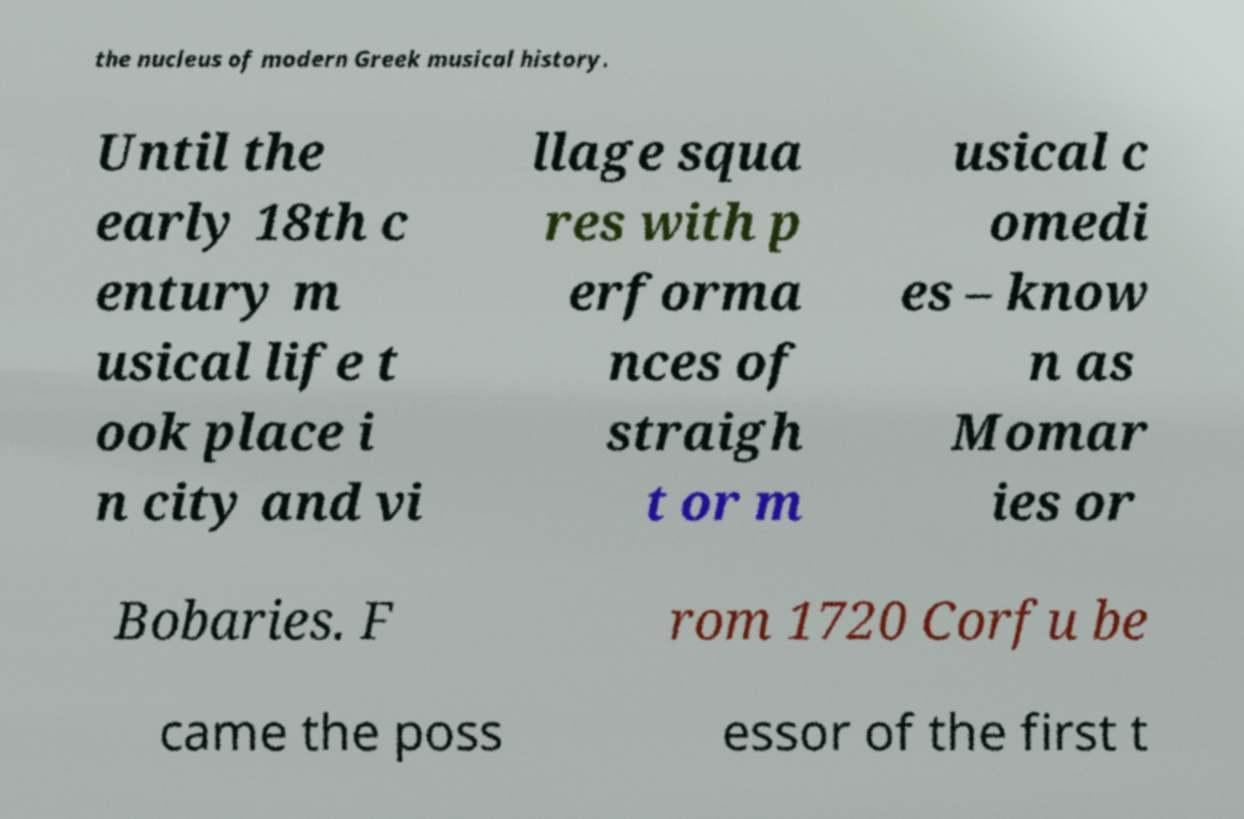There's text embedded in this image that I need extracted. Can you transcribe it verbatim? the nucleus of modern Greek musical history. Until the early 18th c entury m usical life t ook place i n city and vi llage squa res with p erforma nces of straigh t or m usical c omedi es – know n as Momar ies or Bobaries. F rom 1720 Corfu be came the poss essor of the first t 